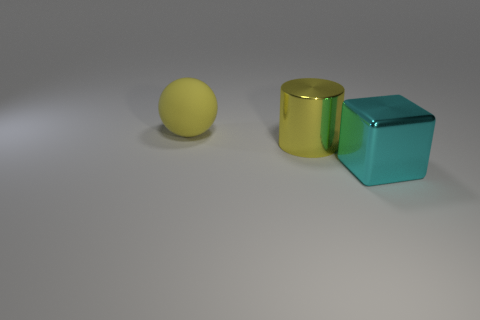Is there another big shiny cylinder of the same color as the large shiny cylinder?
Offer a very short reply. No. Does the big matte object have the same color as the cylinder?
Offer a very short reply. Yes. What is the material of the large cylinder that is the same color as the large rubber sphere?
Ensure brevity in your answer.  Metal. Is the big cyan block made of the same material as the large yellow ball?
Make the answer very short. No. There is a yellow thing that is to the left of the yellow object in front of the yellow object to the left of the cylinder; what is its material?
Offer a terse response. Rubber. Is the shape of the shiny thing to the left of the cyan block the same as the large yellow object behind the metal cylinder?
Provide a succinct answer. No. How many other things are there of the same material as the yellow cylinder?
Provide a succinct answer. 1. Are the big yellow object behind the large yellow metallic object and the yellow object in front of the rubber thing made of the same material?
Give a very brief answer. No. The other object that is made of the same material as the big cyan thing is what shape?
Offer a very short reply. Cylinder. Is there anything else that is the same color as the cylinder?
Make the answer very short. Yes. 